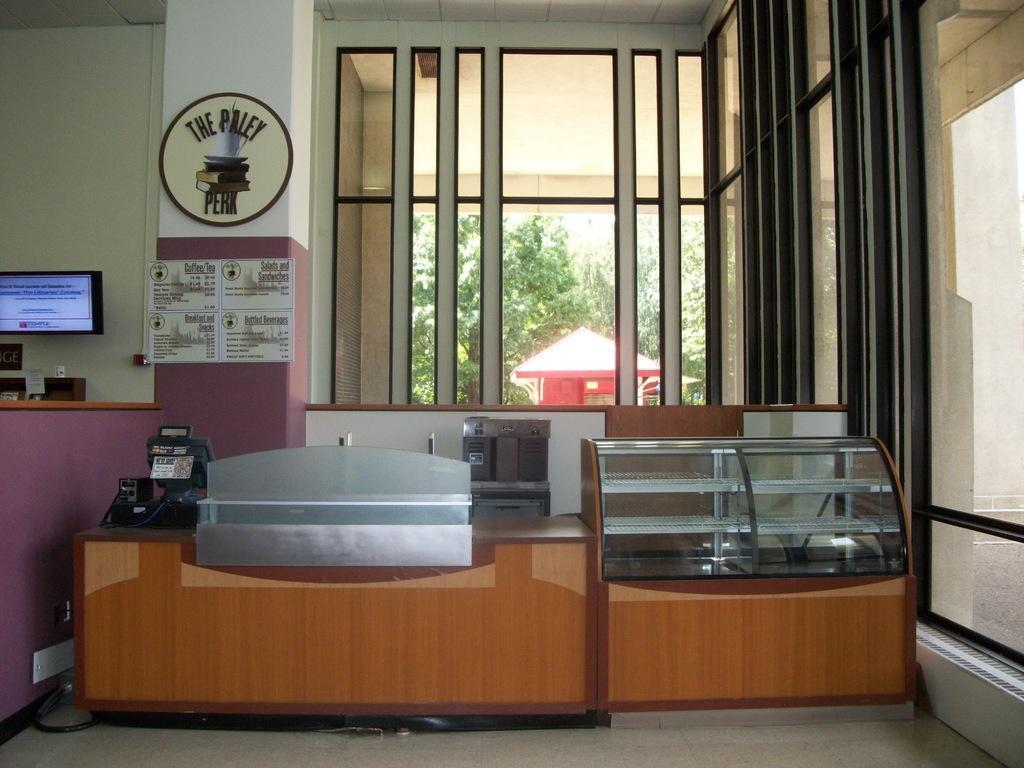Can you describe this image briefly? In this picture I can observe desk in the middle of the picture. In the background I can observe window and some plants. 